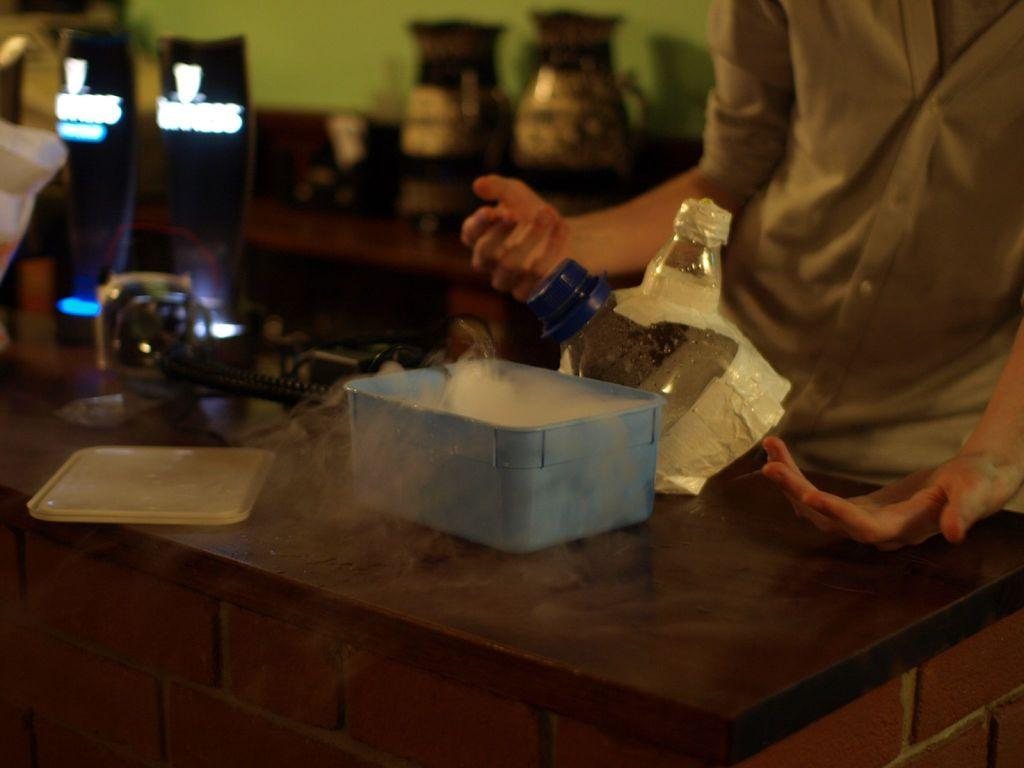What type of furniture is present in the image? There are tables in the image. What object in the image might be used for storage or transportation? There is a container in the image that might be used for storage or transportation. What is the purpose of the lid in the image? The lid in the image is likely used to cover or seal the container. What type of items can be seen in the image? There are bottles in the image. Who or what is present in the image? There is a person in the image. What type of structure is visible in the image? There is a wall in the image. What time of day is it in the image, based on the hour? The provided facts do not mention the time of day or any specific hour, so it is not possible to determine the time from the image. What is the location of the scene in the image, specifically downtown? The provided facts do not mention the location of the scene or any specific reference to downtown, so it is not possible to determine the location from the image. 